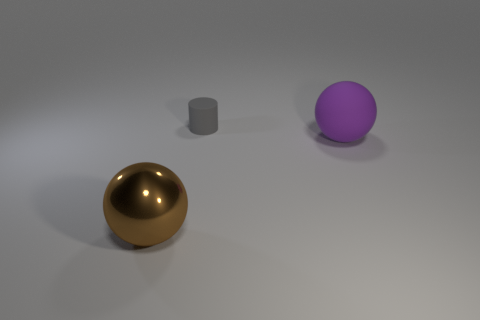Add 3 green matte cylinders. How many objects exist? 6 Subtract all spheres. How many objects are left? 1 Subtract 1 purple balls. How many objects are left? 2 Subtract all rubber things. Subtract all tiny gray matte things. How many objects are left? 0 Add 2 rubber things. How many rubber things are left? 4 Add 1 tiny objects. How many tiny objects exist? 2 